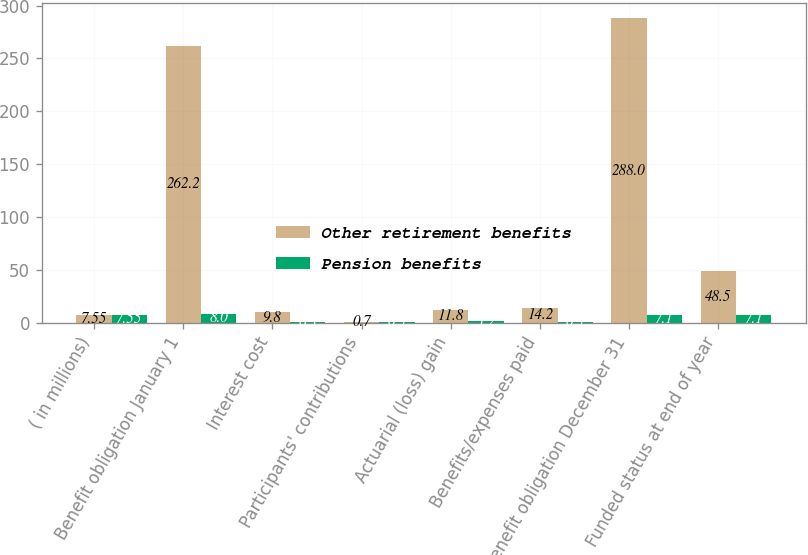Convert chart. <chart><loc_0><loc_0><loc_500><loc_500><stacked_bar_chart><ecel><fcel>( in millions)<fcel>Benefit obligation January 1<fcel>Interest cost<fcel>Participants' contributions<fcel>Actuarial (loss) gain<fcel>Benefits/expenses paid<fcel>Benefit obligation December 31<fcel>Funded status at end of year<nl><fcel>Other retirement benefits<fcel>7.55<fcel>262.2<fcel>9.8<fcel>0.7<fcel>11.8<fcel>14.2<fcel>288<fcel>48.5<nl><fcel>Pension benefits<fcel>7.55<fcel>8<fcel>0.3<fcel>0.5<fcel>1.2<fcel>0.5<fcel>7.1<fcel>7.1<nl></chart> 